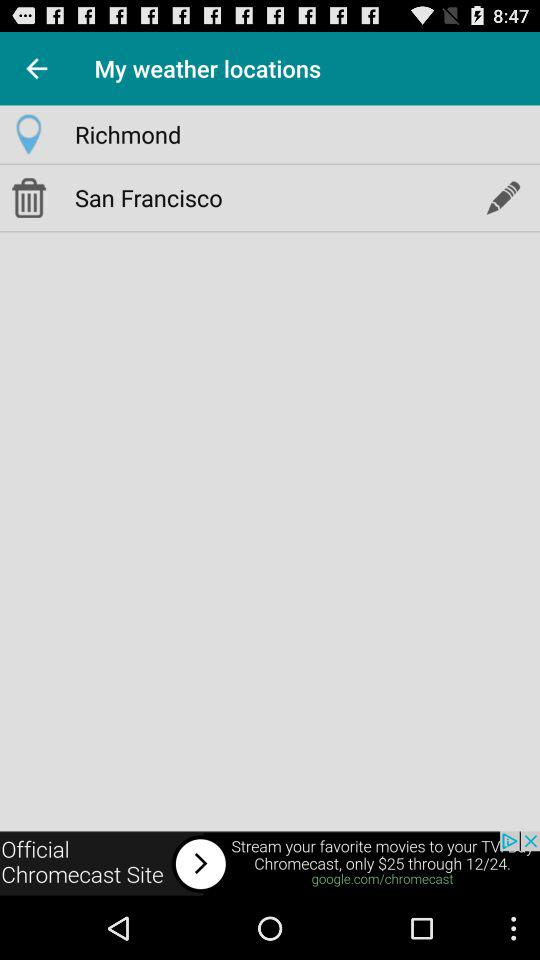What is the last saved location? The last saved location is San Francisco. 